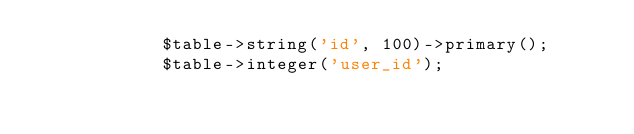Convert code to text. <code><loc_0><loc_0><loc_500><loc_500><_PHP_>            $table->string('id', 100)->primary();
            $table->integer('user_id');</code> 